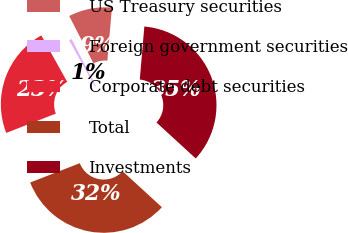<chart> <loc_0><loc_0><loc_500><loc_500><pie_chart><fcel>US Treasury securities<fcel>Foreign government securities<fcel>Corporate debt securities<fcel>Total<fcel>Investments<nl><fcel>8.9%<fcel>0.56%<fcel>22.82%<fcel>32.28%<fcel>35.45%<nl></chart> 